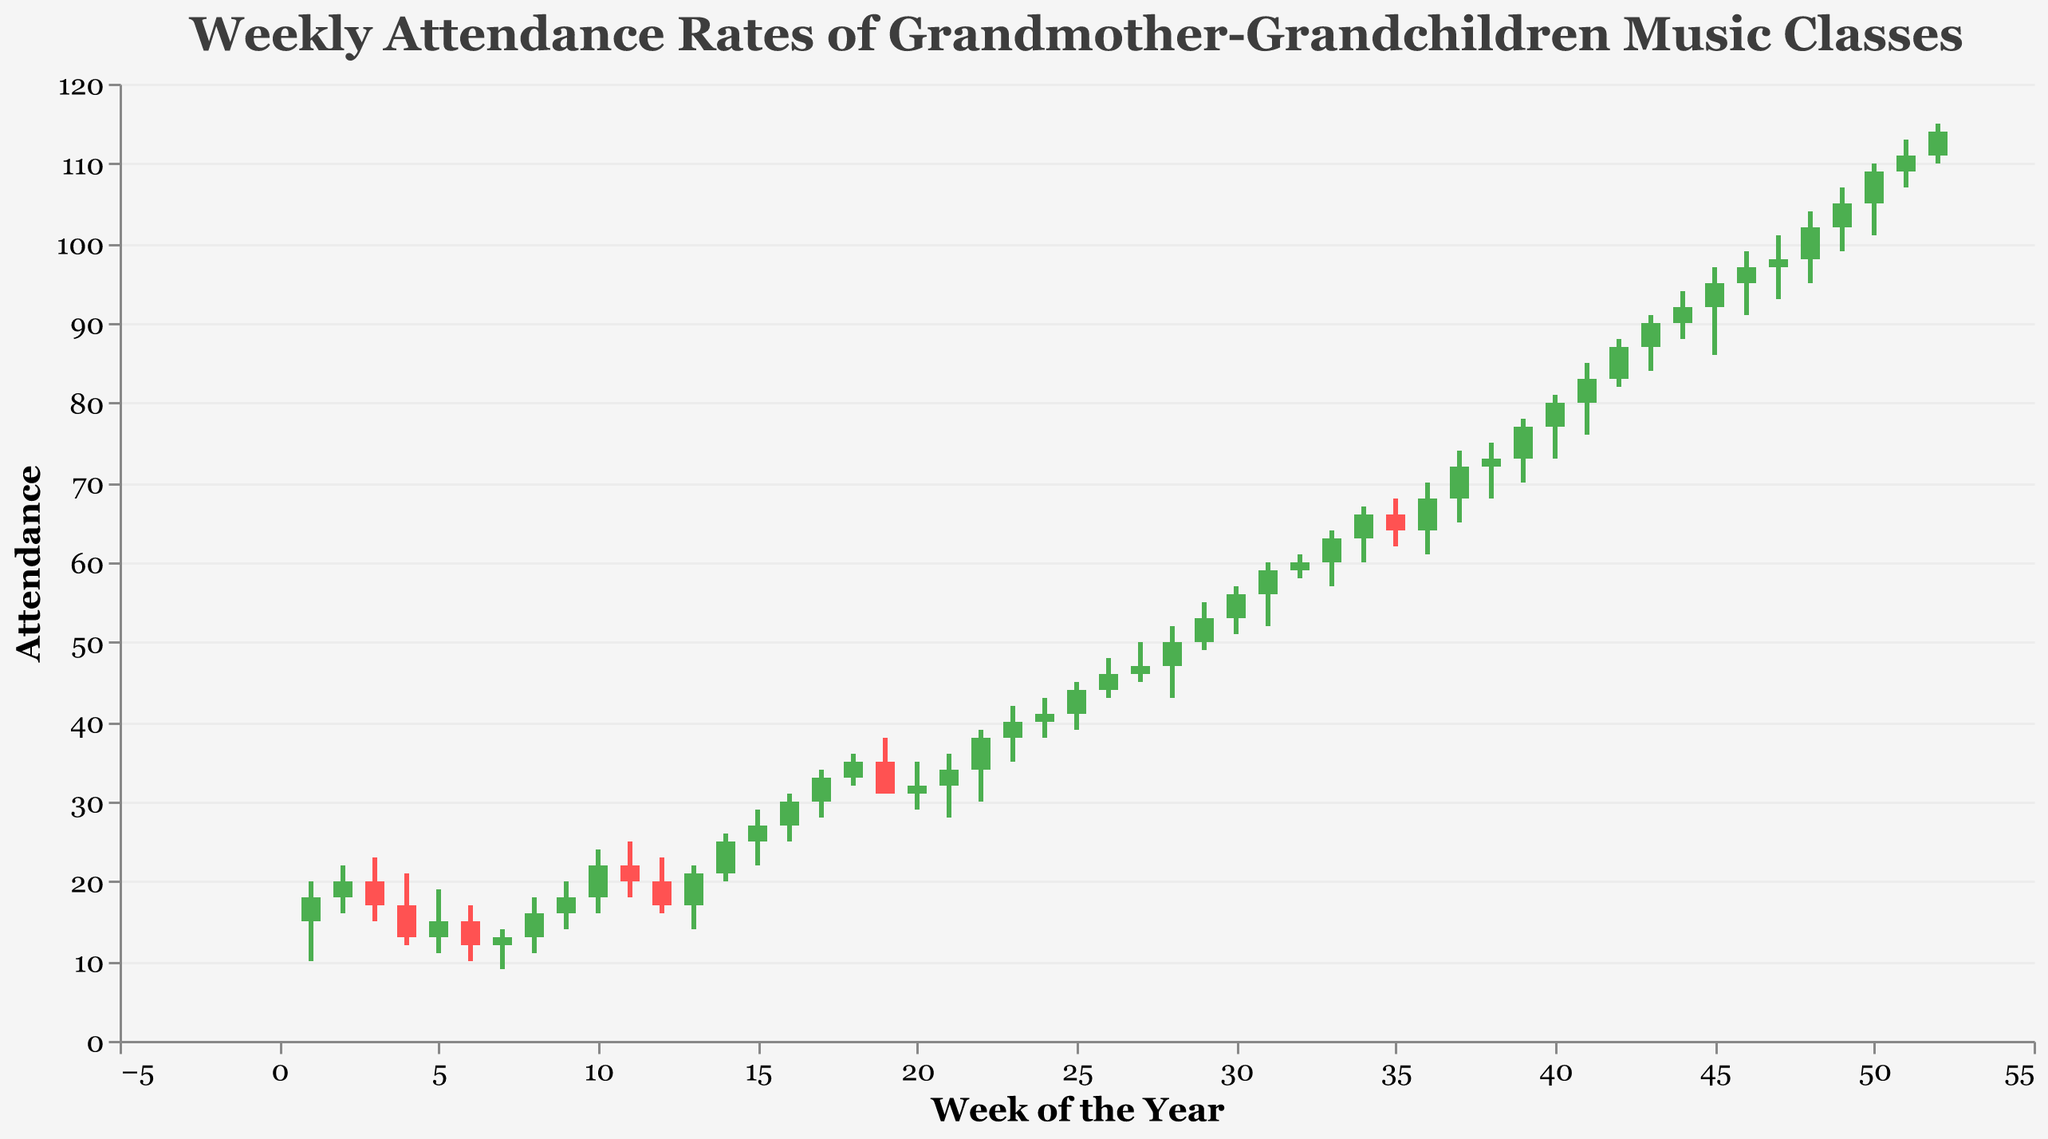What is the title of the plot? The title is displayed at the top of the plot and typically describes the subject of the data being visualized.
Answer: Weekly Attendance Rates of Grandmother-Grandchildren Music Classes What is the attendance range in Week 1? The range can be determined by looking at the lowest and highest values in Week 1. The Low value is 10 and the High value is 20.
Answer: 10 to 20 In which week did the attendance open exactly at 50? To find this, we look for the week where the "Open" value is 50. This occurs in Week 29.
Answer: Week 29 In which week did the attendance close higher than it opened by exactly 20 units? We need to find a week where the "Close" value is 20 units higher than the "Open" value. This happens in Week 42 (Close: 87, Open: 83).
Answer: Week 42 Which week had the highest overall attendance (High value) and what was the value? The highest overall attendance can be found by looking for the maximum "High" value across all weeks. The highest value is 115 in Week 52.
Answer: Week 52, 115 What was the average closing attendance in the first 10 weeks? To find the average, sum the "Close" values for the first 10 weeks and divide by 10. The values are 18, 20, 17, 13, 15, 12, 13, 16, 18, 22. The sum is 164. The average is 164/10 = 16.4.
Answer: 16.4 Which week experienced the largest drop in attendance between Open and Close? The week with the largest drop in attendance will have the highest difference between the "Open" and "Close" values where the "Close" is less than the "Open". Week 19 has the largest drop with (Open: 35, Close: 31), which is 4 units drop.
Answer: Week 19 What was the lowest closing attendance in the entire year? The lowest closing attendance can be identified by finding the minimum "Close" value across all weeks. The lowest value is 12 in Week 6.
Answer: 12 How many weeks had the closing attendance greater than the opening attendance? This can be calculated by counting the number of weeks where the "Close" value is greater than the "Open" value. There are 29 such weeks.
Answer: 29 weeks Between Week 35 and Week 40, which week had the highest closing attendance? To answer this, compare the "Close" values from Week 35 to Week 40. Week 40 has the highest closing attendance of 80.
Answer: Week 40, 80 